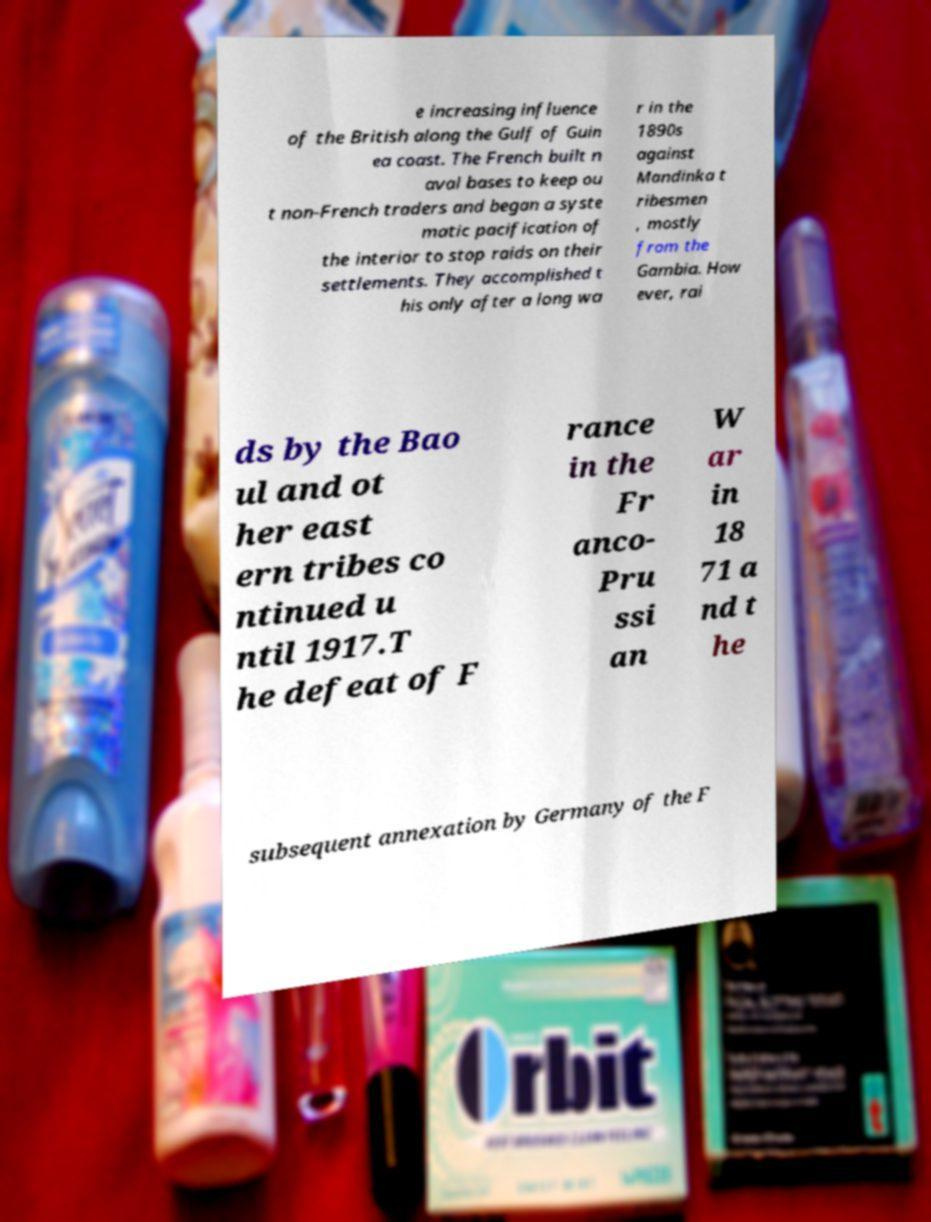Could you assist in decoding the text presented in this image and type it out clearly? e increasing influence of the British along the Gulf of Guin ea coast. The French built n aval bases to keep ou t non-French traders and began a syste matic pacification of the interior to stop raids on their settlements. They accomplished t his only after a long wa r in the 1890s against Mandinka t ribesmen , mostly from the Gambia. How ever, rai ds by the Bao ul and ot her east ern tribes co ntinued u ntil 1917.T he defeat of F rance in the Fr anco- Pru ssi an W ar in 18 71 a nd t he subsequent annexation by Germany of the F 